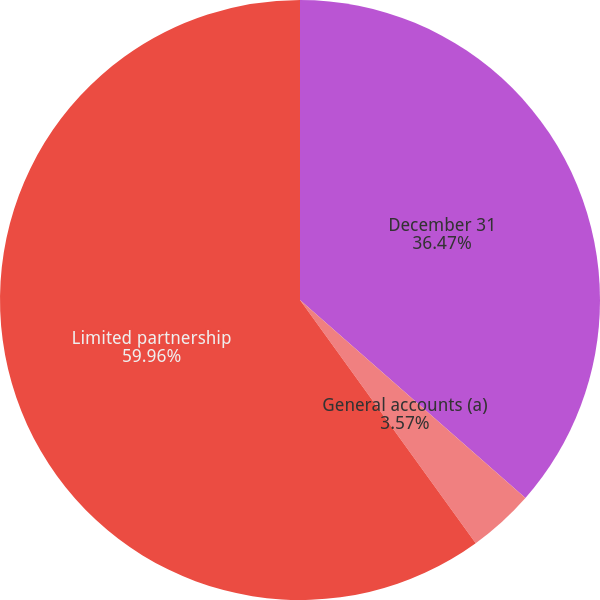Convert chart to OTSL. <chart><loc_0><loc_0><loc_500><loc_500><pie_chart><fcel>December 31<fcel>General accounts (a)<fcel>Limited partnership<nl><fcel>36.47%<fcel>3.57%<fcel>59.96%<nl></chart> 